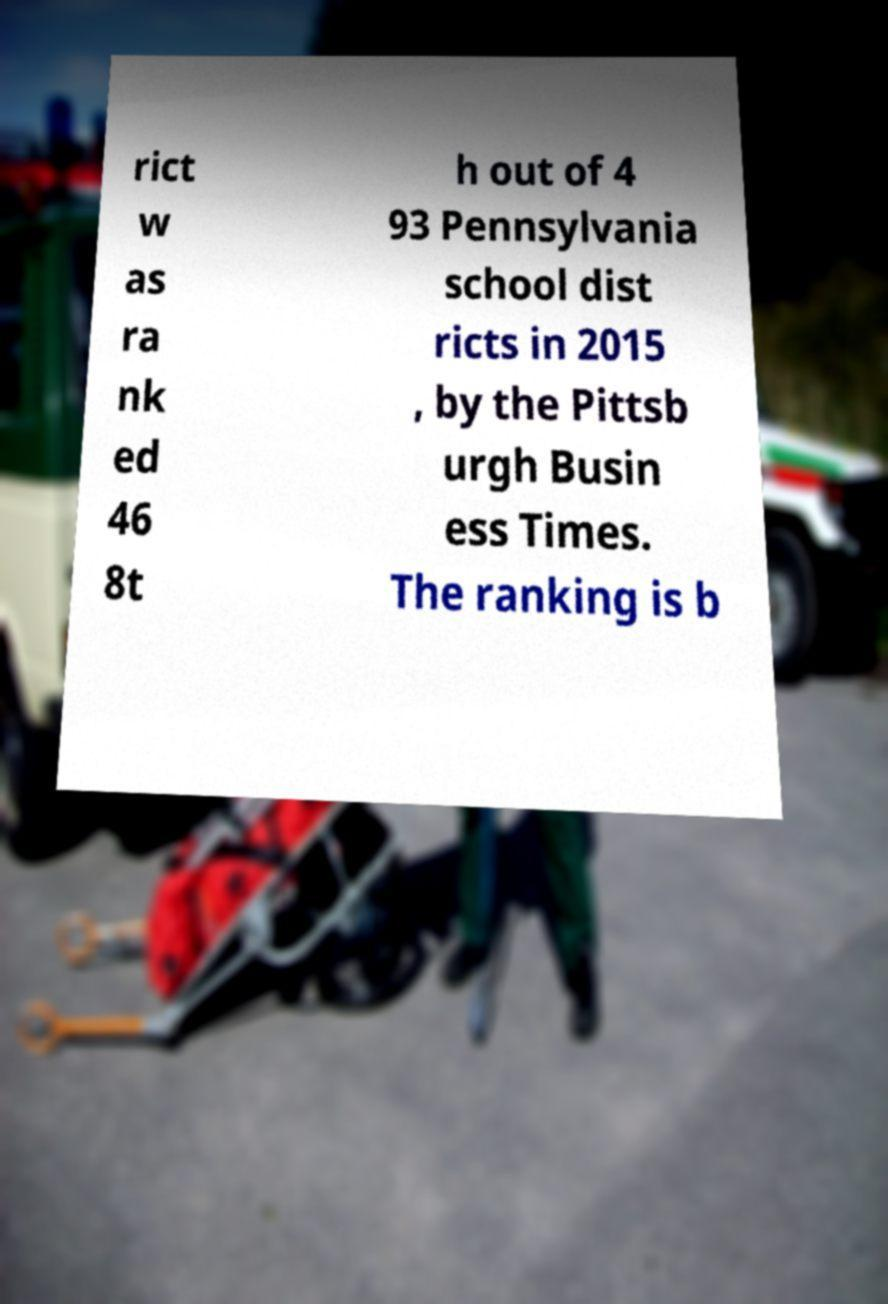For documentation purposes, I need the text within this image transcribed. Could you provide that? rict w as ra nk ed 46 8t h out of 4 93 Pennsylvania school dist ricts in 2015 , by the Pittsb urgh Busin ess Times. The ranking is b 